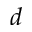<formula> <loc_0><loc_0><loc_500><loc_500>d</formula> 